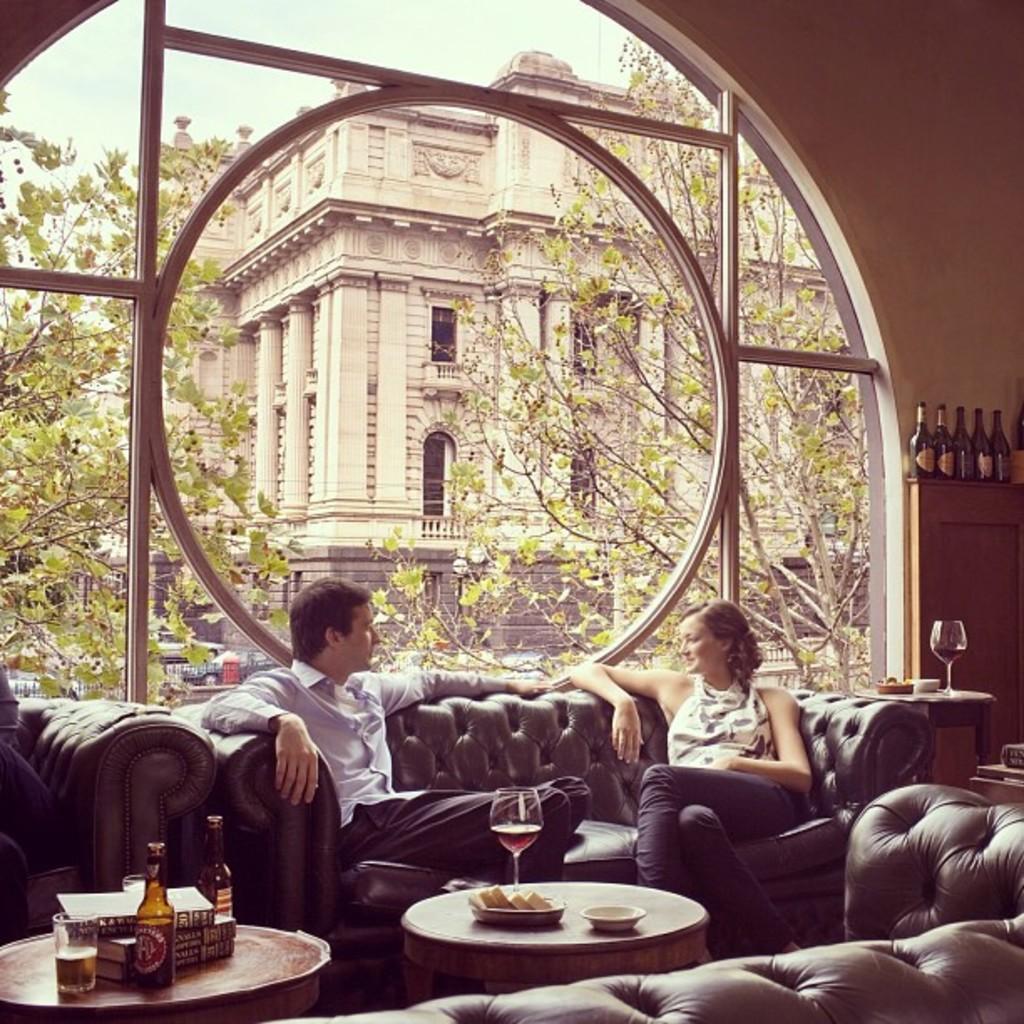Could you give a brief overview of what you see in this image? In this picture we can see a man wearing blue shirt and black pant is sitting on the black couch and a girl beside her discussing something. In front a center table on which wine glass and food is kept, beside another table on which wine bottle, glass and tissue paper box is kept. Behind we can see the a big glass wall panel from which a arch design building and tree can be seen, Inside on the right corner we can see some wine bottles on the top of the cabinet and a wine glass on the table placed on the floor. 